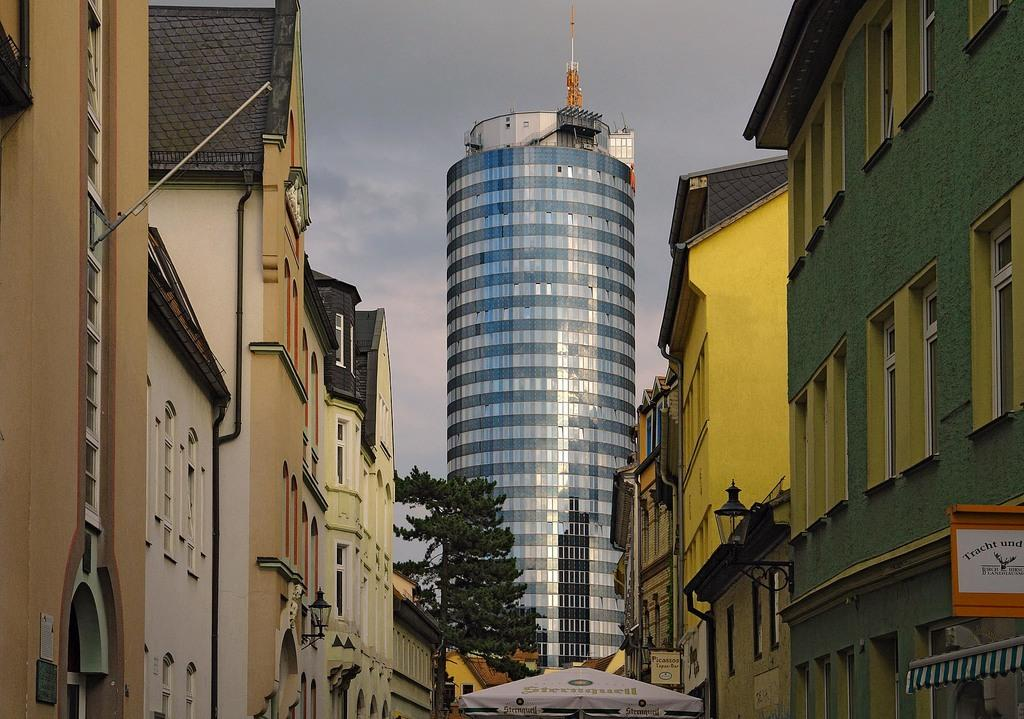What type of structures can be seen in the image? There are buildings in the image. What architectural features are present on the buildings? There are windows in the image. What other objects can be seen in the image? There are boards, lights, a tree, and a tent in the image. What is visible in the background of the image? The sky with clouds is visible in the background of the image. What type of flower is growing near the tent in the image? There is no flower visible near the tent in the image. Can you see an airplane flying in the sky in the image? No, there is no airplane visible in the sky in the image. 